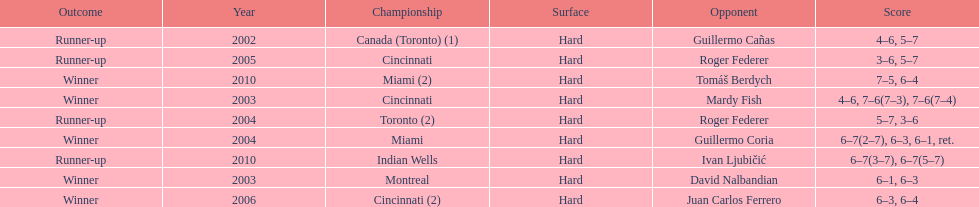What was the highest number of consecutive wins? 3. 